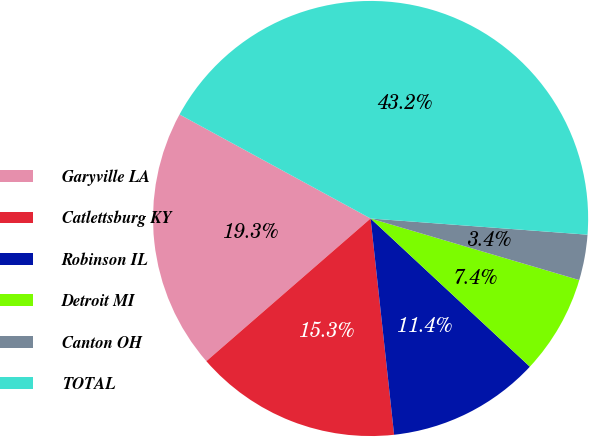Convert chart. <chart><loc_0><loc_0><loc_500><loc_500><pie_chart><fcel>Garyville LA<fcel>Catlettsburg KY<fcel>Robinson IL<fcel>Detroit MI<fcel>Canton OH<fcel>TOTAL<nl><fcel>19.32%<fcel>15.34%<fcel>11.35%<fcel>7.36%<fcel>3.38%<fcel>43.25%<nl></chart> 